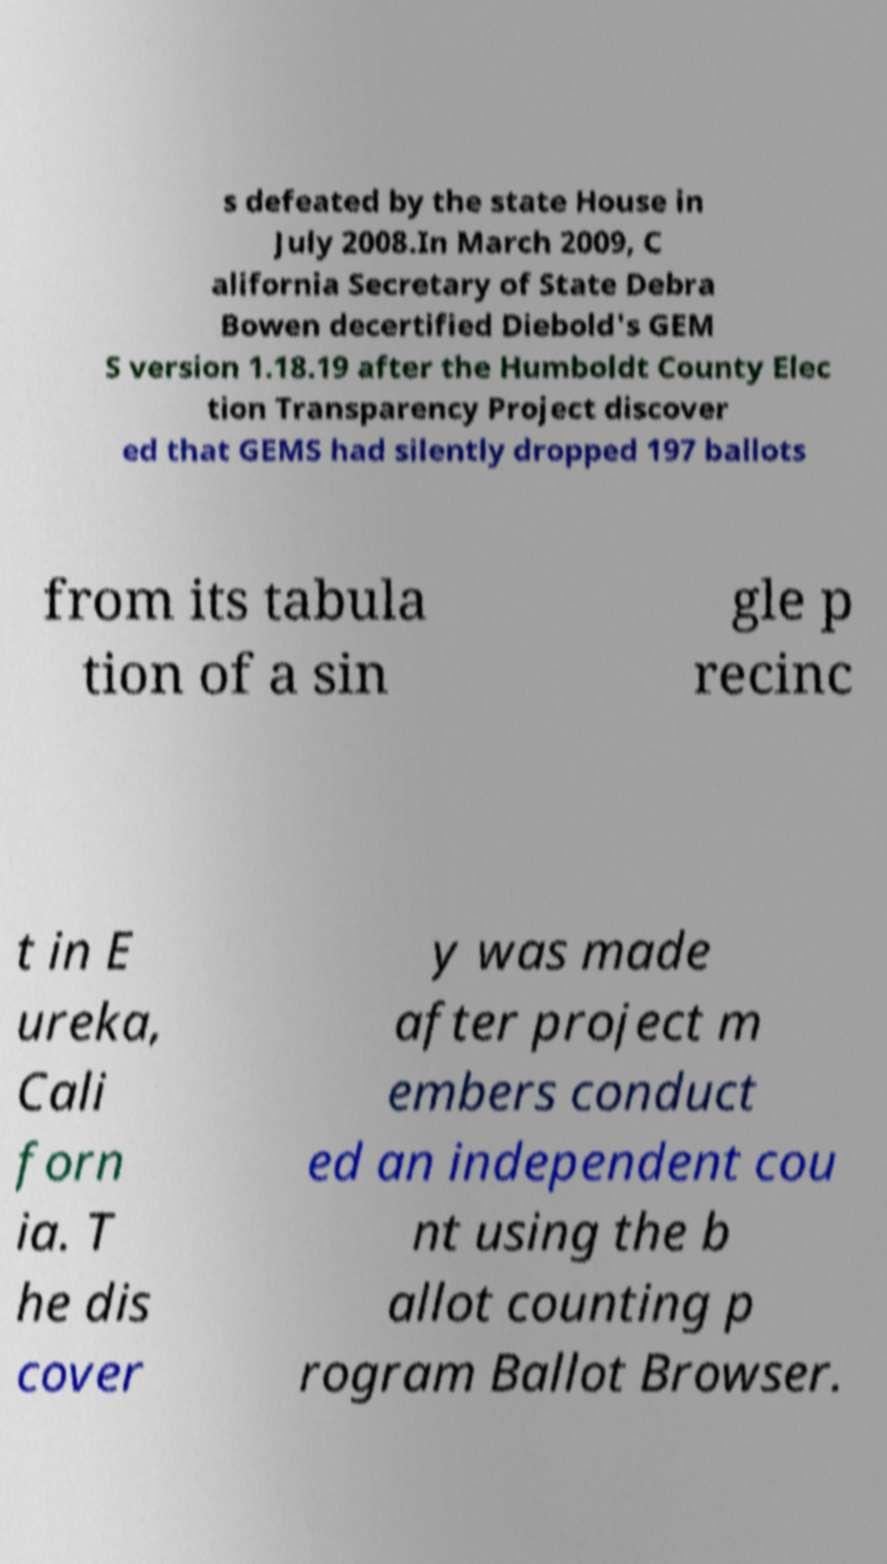Could you assist in decoding the text presented in this image and type it out clearly? s defeated by the state House in July 2008.In March 2009, C alifornia Secretary of State Debra Bowen decertified Diebold's GEM S version 1.18.19 after the Humboldt County Elec tion Transparency Project discover ed that GEMS had silently dropped 197 ballots from its tabula tion of a sin gle p recinc t in E ureka, Cali forn ia. T he dis cover y was made after project m embers conduct ed an independent cou nt using the b allot counting p rogram Ballot Browser. 